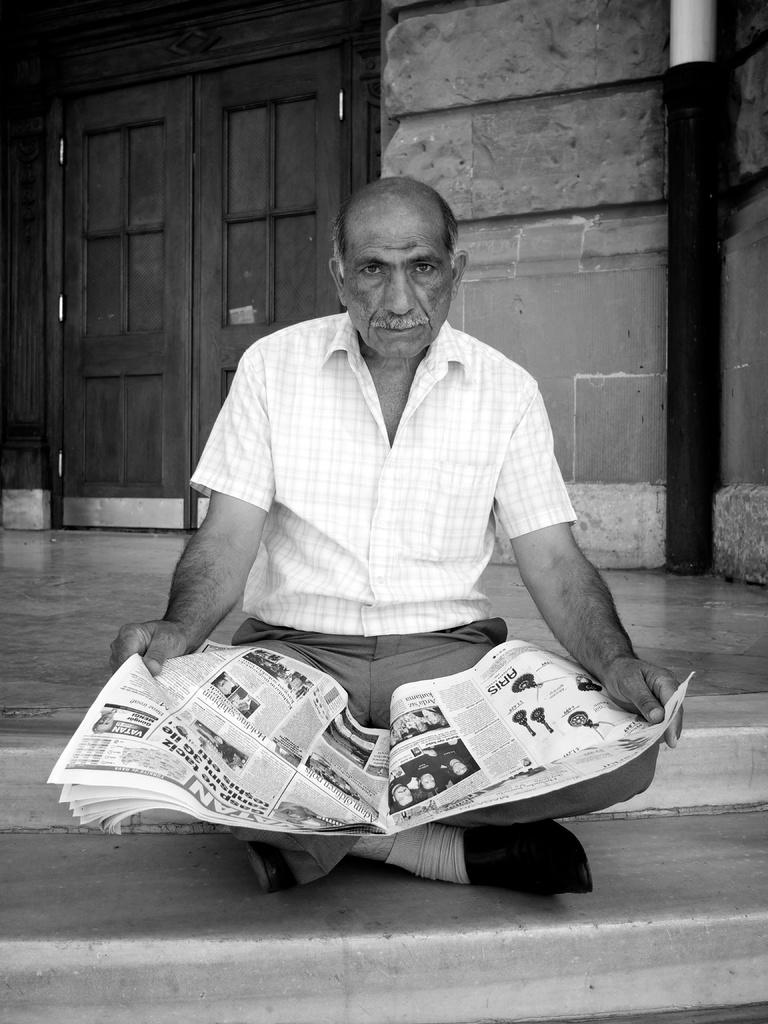What is the color scheme of the image? The image is black and white. What is the person in the image doing? The person is sitting on the stairs and holding a newspaper. What can be seen behind the person? There is a door of a building behind the person. What type of potato is being attacked by a squirrel in the image? There is no potato or squirrel present in the image. Are there any curtains visible in the image? No, there are no curtains visible in the image. 